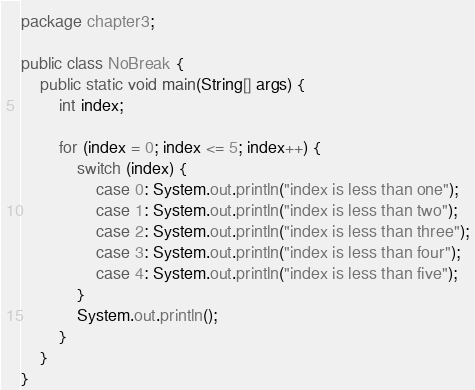<code> <loc_0><loc_0><loc_500><loc_500><_Java_>package chapter3;

public class NoBreak {
    public static void main(String[] args) {
        int index;

        for (index = 0; index <= 5; index++) {
            switch (index) {
                case 0: System.out.println("index is less than one");
                case 1: System.out.println("index is less than two");
                case 2: System.out.println("index is less than three");
                case 3: System.out.println("index is less than four");
                case 4: System.out.println("index is less than five");
            }
            System.out.println();
        }
    }
}
</code> 